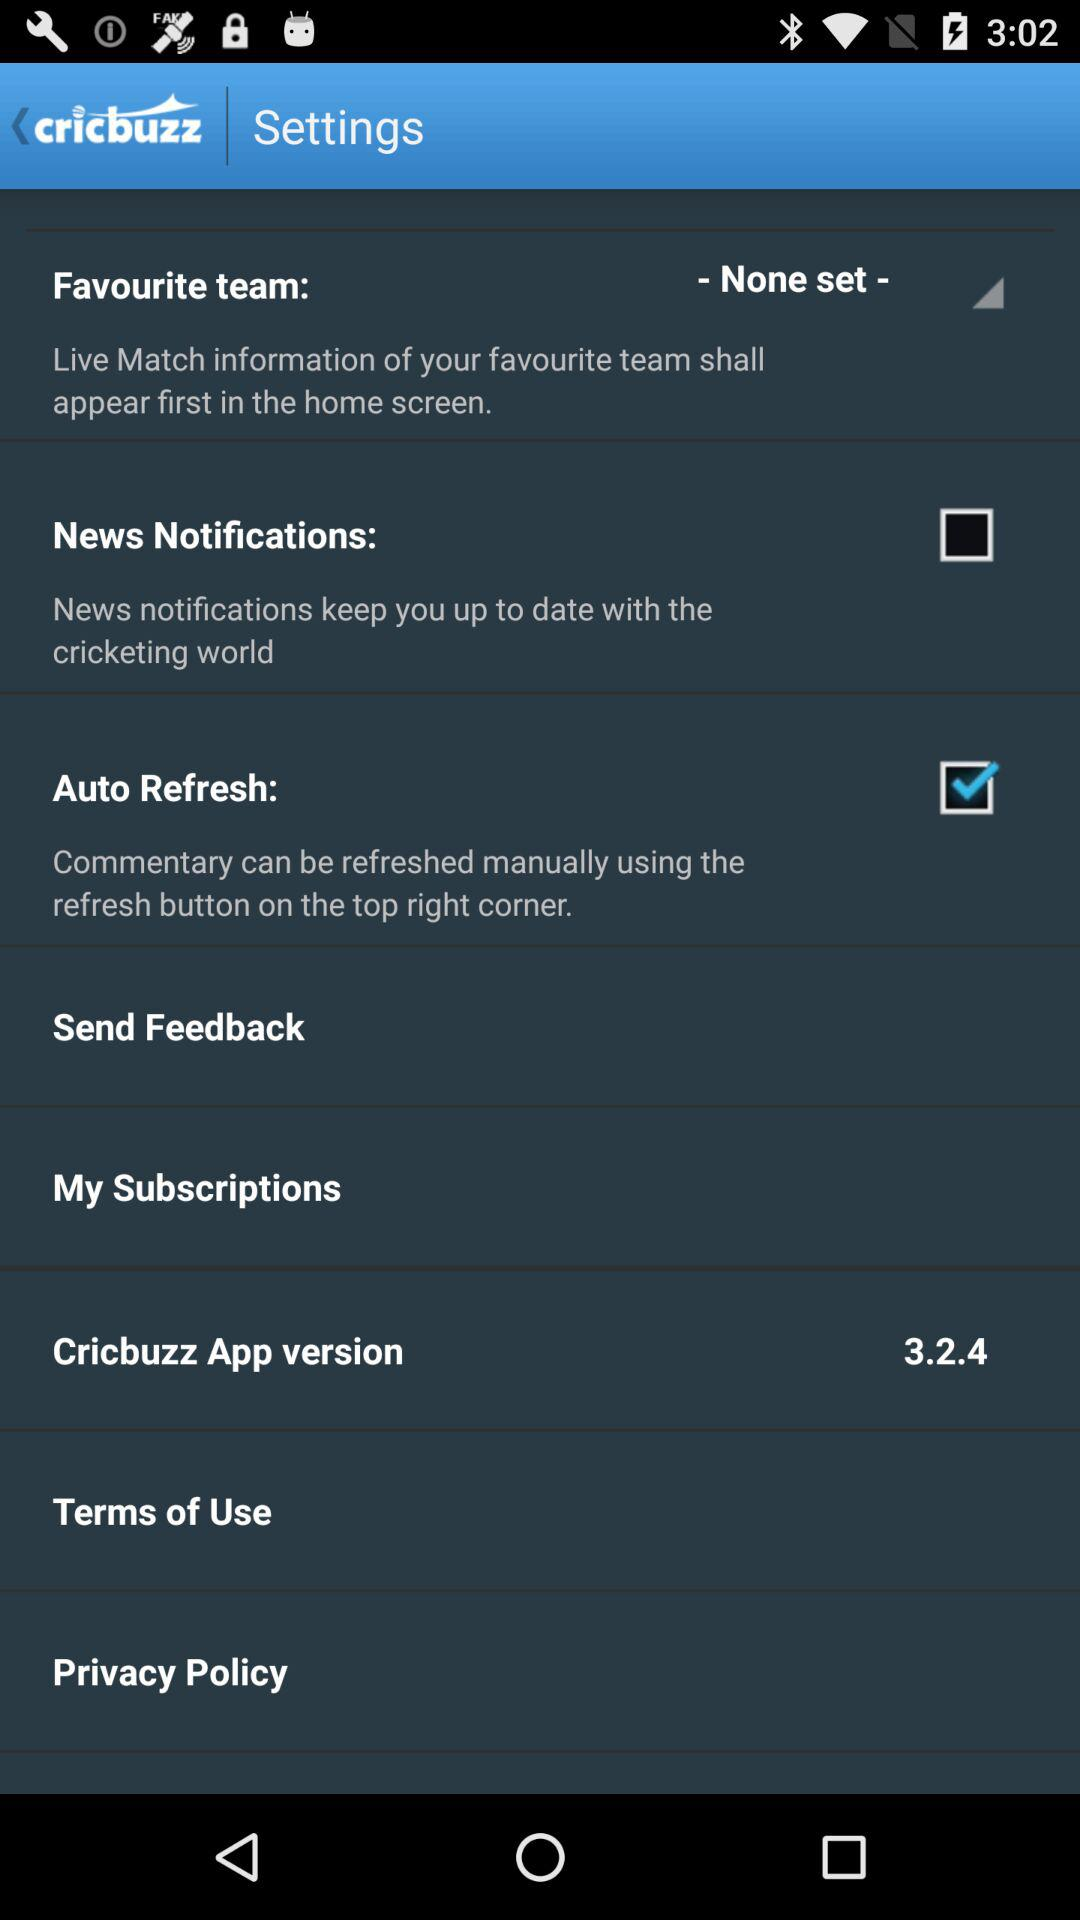What is the version of the "Cricbuzz" app? The version is 3.2.4. 